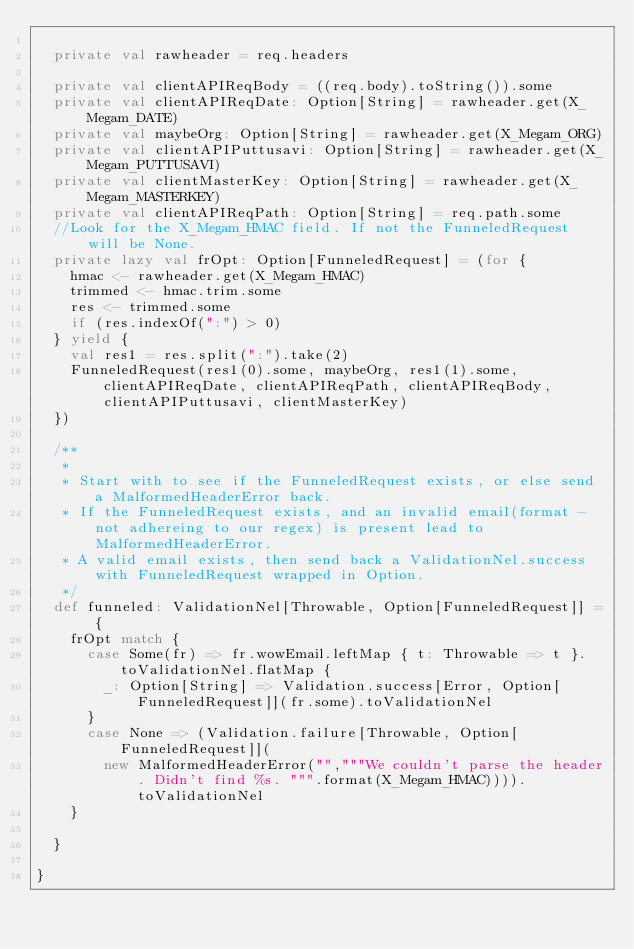Convert code to text. <code><loc_0><loc_0><loc_500><loc_500><_Scala_>
  private val rawheader = req.headers

  private val clientAPIReqBody = ((req.body).toString()).some
  private val clientAPIReqDate: Option[String] = rawheader.get(X_Megam_DATE)
  private val maybeOrg: Option[String] = rawheader.get(X_Megam_ORG)
  private val clientAPIPuttusavi: Option[String] = rawheader.get(X_Megam_PUTTUSAVI)
  private val clientMasterKey: Option[String] = rawheader.get(X_Megam_MASTERKEY)
  private val clientAPIReqPath: Option[String] = req.path.some
  //Look for the X_Megam_HMAC field. If not the FunneledRequest will be None.
  private lazy val frOpt: Option[FunneledRequest] = (for {
    hmac <- rawheader.get(X_Megam_HMAC)
    trimmed <- hmac.trim.some
    res <- trimmed.some
    if (res.indexOf(":") > 0)
  } yield {
    val res1 = res.split(":").take(2)
    FunneledRequest(res1(0).some, maybeOrg, res1(1).some, clientAPIReqDate, clientAPIReqPath, clientAPIReqBody, clientAPIPuttusavi, clientMasterKey)
  })

  /**
   *
   * Start with to see if the FunneledRequest exists, or else send a MalformedHeaderError back.
   * If the FunneledRequest exists, and an invalid email(format - not adhereing to our regex) is present lead to MalformedHeaderError.
   * A valid email exists, then send back a ValidationNel.success with FunneledRequest wrapped in Option.
   */
  def funneled: ValidationNel[Throwable, Option[FunneledRequest]] = {
    frOpt match {
      case Some(fr) => fr.wowEmail.leftMap { t: Throwable => t }.toValidationNel.flatMap {
        _: Option[String] => Validation.success[Error, Option[FunneledRequest]](fr.some).toValidationNel
      }
      case None => (Validation.failure[Throwable, Option[FunneledRequest]](
        new MalformedHeaderError("","""We couldn't parse the header. Didn't find %s. """.format(X_Megam_HMAC)))).toValidationNel
    }

  }

}
</code> 